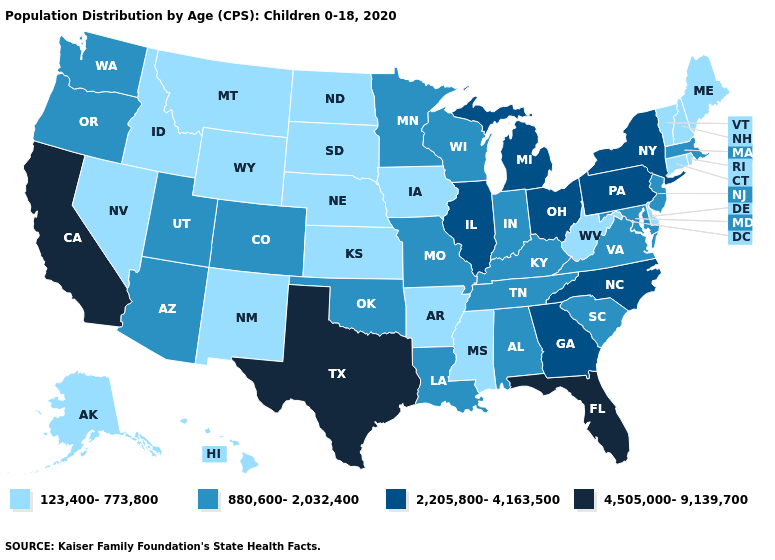Name the states that have a value in the range 2,205,800-4,163,500?
Concise answer only. Georgia, Illinois, Michigan, New York, North Carolina, Ohio, Pennsylvania. What is the highest value in states that border Rhode Island?
Be succinct. 880,600-2,032,400. Does Rhode Island have the same value as New Mexico?
Short answer required. Yes. What is the highest value in the MidWest ?
Be succinct. 2,205,800-4,163,500. Which states have the highest value in the USA?
Short answer required. California, Florida, Texas. What is the value of Virginia?
Write a very short answer. 880,600-2,032,400. What is the value of Illinois?
Concise answer only. 2,205,800-4,163,500. Does Washington have a lower value than Alabama?
Keep it brief. No. Does Florida have a lower value than Louisiana?
Write a very short answer. No. What is the lowest value in the USA?
Quick response, please. 123,400-773,800. Is the legend a continuous bar?
Short answer required. No. What is the highest value in the West ?
Quick response, please. 4,505,000-9,139,700. What is the value of Washington?
Answer briefly. 880,600-2,032,400. Which states have the lowest value in the West?
Write a very short answer. Alaska, Hawaii, Idaho, Montana, Nevada, New Mexico, Wyoming. What is the lowest value in states that border Ohio?
Short answer required. 123,400-773,800. 